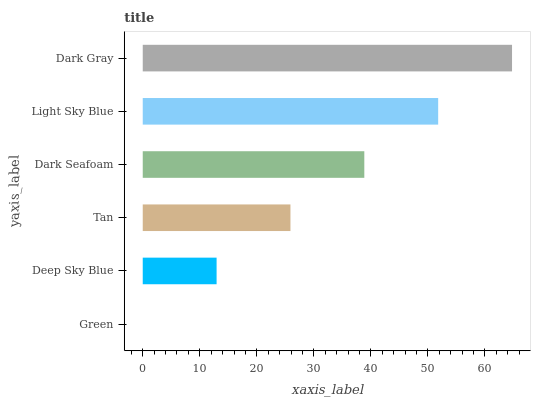Is Green the minimum?
Answer yes or no. Yes. Is Dark Gray the maximum?
Answer yes or no. Yes. Is Deep Sky Blue the minimum?
Answer yes or no. No. Is Deep Sky Blue the maximum?
Answer yes or no. No. Is Deep Sky Blue greater than Green?
Answer yes or no. Yes. Is Green less than Deep Sky Blue?
Answer yes or no. Yes. Is Green greater than Deep Sky Blue?
Answer yes or no. No. Is Deep Sky Blue less than Green?
Answer yes or no. No. Is Dark Seafoam the high median?
Answer yes or no. Yes. Is Tan the low median?
Answer yes or no. Yes. Is Tan the high median?
Answer yes or no. No. Is Dark Gray the low median?
Answer yes or no. No. 